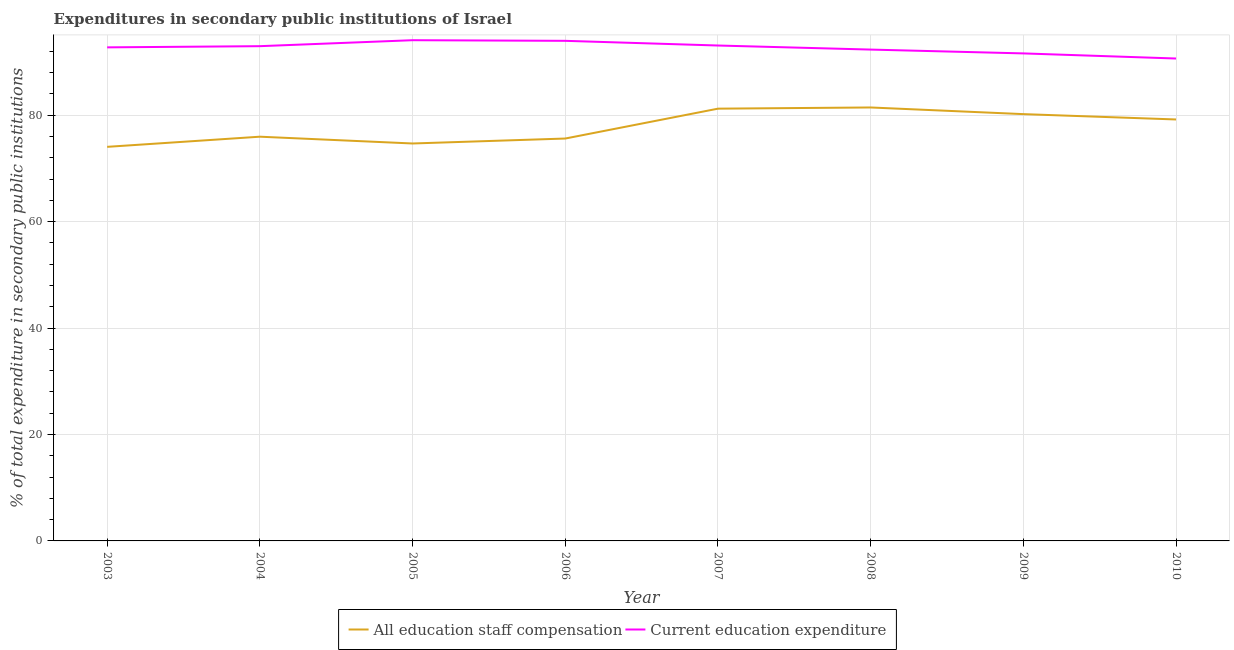How many different coloured lines are there?
Offer a terse response. 2. Does the line corresponding to expenditure in staff compensation intersect with the line corresponding to expenditure in education?
Provide a short and direct response. No. Is the number of lines equal to the number of legend labels?
Your response must be concise. Yes. What is the expenditure in staff compensation in 2010?
Give a very brief answer. 79.21. Across all years, what is the maximum expenditure in staff compensation?
Make the answer very short. 81.47. Across all years, what is the minimum expenditure in education?
Offer a very short reply. 90.67. What is the total expenditure in education in the graph?
Make the answer very short. 741.61. What is the difference between the expenditure in staff compensation in 2003 and that in 2008?
Your answer should be compact. -7.4. What is the difference between the expenditure in staff compensation in 2003 and the expenditure in education in 2009?
Provide a succinct answer. -17.56. What is the average expenditure in education per year?
Your response must be concise. 92.7. In the year 2003, what is the difference between the expenditure in staff compensation and expenditure in education?
Provide a short and direct response. -18.7. What is the ratio of the expenditure in staff compensation in 2006 to that in 2007?
Your answer should be compact. 0.93. What is the difference between the highest and the second highest expenditure in education?
Provide a short and direct response. 0.12. What is the difference between the highest and the lowest expenditure in staff compensation?
Your response must be concise. 7.4. In how many years, is the expenditure in education greater than the average expenditure in education taken over all years?
Offer a very short reply. 5. Does the expenditure in education monotonically increase over the years?
Offer a very short reply. No. Is the expenditure in education strictly greater than the expenditure in staff compensation over the years?
Your answer should be very brief. Yes. Does the graph contain any zero values?
Make the answer very short. No. Does the graph contain grids?
Give a very brief answer. Yes. Where does the legend appear in the graph?
Your answer should be compact. Bottom center. How are the legend labels stacked?
Keep it short and to the point. Horizontal. What is the title of the graph?
Offer a very short reply. Expenditures in secondary public institutions of Israel. What is the label or title of the Y-axis?
Your response must be concise. % of total expenditure in secondary public institutions. What is the % of total expenditure in secondary public institutions of All education staff compensation in 2003?
Offer a very short reply. 74.07. What is the % of total expenditure in secondary public institutions in Current education expenditure in 2003?
Provide a short and direct response. 92.77. What is the % of total expenditure in secondary public institutions of All education staff compensation in 2004?
Provide a short and direct response. 75.97. What is the % of total expenditure in secondary public institutions of Current education expenditure in 2004?
Offer a very short reply. 92.99. What is the % of total expenditure in secondary public institutions in All education staff compensation in 2005?
Make the answer very short. 74.7. What is the % of total expenditure in secondary public institutions of Current education expenditure in 2005?
Ensure brevity in your answer.  94.11. What is the % of total expenditure in secondary public institutions in All education staff compensation in 2006?
Ensure brevity in your answer.  75.63. What is the % of total expenditure in secondary public institutions in Current education expenditure in 2006?
Keep it short and to the point. 93.99. What is the % of total expenditure in secondary public institutions of All education staff compensation in 2007?
Keep it short and to the point. 81.24. What is the % of total expenditure in secondary public institutions of Current education expenditure in 2007?
Provide a succinct answer. 93.11. What is the % of total expenditure in secondary public institutions in All education staff compensation in 2008?
Provide a short and direct response. 81.47. What is the % of total expenditure in secondary public institutions of Current education expenditure in 2008?
Your answer should be compact. 92.35. What is the % of total expenditure in secondary public institutions in All education staff compensation in 2009?
Provide a short and direct response. 80.22. What is the % of total expenditure in secondary public institutions in Current education expenditure in 2009?
Offer a terse response. 91.63. What is the % of total expenditure in secondary public institutions of All education staff compensation in 2010?
Your answer should be compact. 79.21. What is the % of total expenditure in secondary public institutions in Current education expenditure in 2010?
Your response must be concise. 90.67. Across all years, what is the maximum % of total expenditure in secondary public institutions of All education staff compensation?
Keep it short and to the point. 81.47. Across all years, what is the maximum % of total expenditure in secondary public institutions in Current education expenditure?
Give a very brief answer. 94.11. Across all years, what is the minimum % of total expenditure in secondary public institutions of All education staff compensation?
Your answer should be compact. 74.07. Across all years, what is the minimum % of total expenditure in secondary public institutions in Current education expenditure?
Your answer should be very brief. 90.67. What is the total % of total expenditure in secondary public institutions in All education staff compensation in the graph?
Provide a short and direct response. 622.51. What is the total % of total expenditure in secondary public institutions of Current education expenditure in the graph?
Keep it short and to the point. 741.61. What is the difference between the % of total expenditure in secondary public institutions in All education staff compensation in 2003 and that in 2004?
Ensure brevity in your answer.  -1.91. What is the difference between the % of total expenditure in secondary public institutions in Current education expenditure in 2003 and that in 2004?
Keep it short and to the point. -0.22. What is the difference between the % of total expenditure in secondary public institutions in All education staff compensation in 2003 and that in 2005?
Your answer should be compact. -0.63. What is the difference between the % of total expenditure in secondary public institutions in Current education expenditure in 2003 and that in 2005?
Provide a short and direct response. -1.34. What is the difference between the % of total expenditure in secondary public institutions of All education staff compensation in 2003 and that in 2006?
Your answer should be compact. -1.56. What is the difference between the % of total expenditure in secondary public institutions of Current education expenditure in 2003 and that in 2006?
Give a very brief answer. -1.23. What is the difference between the % of total expenditure in secondary public institutions of All education staff compensation in 2003 and that in 2007?
Give a very brief answer. -7.18. What is the difference between the % of total expenditure in secondary public institutions in Current education expenditure in 2003 and that in 2007?
Provide a succinct answer. -0.35. What is the difference between the % of total expenditure in secondary public institutions in All education staff compensation in 2003 and that in 2008?
Ensure brevity in your answer.  -7.4. What is the difference between the % of total expenditure in secondary public institutions of Current education expenditure in 2003 and that in 2008?
Keep it short and to the point. 0.42. What is the difference between the % of total expenditure in secondary public institutions in All education staff compensation in 2003 and that in 2009?
Provide a succinct answer. -6.15. What is the difference between the % of total expenditure in secondary public institutions of Current education expenditure in 2003 and that in 2009?
Your answer should be compact. 1.14. What is the difference between the % of total expenditure in secondary public institutions of All education staff compensation in 2003 and that in 2010?
Your answer should be very brief. -5.15. What is the difference between the % of total expenditure in secondary public institutions of Current education expenditure in 2003 and that in 2010?
Offer a very short reply. 2.1. What is the difference between the % of total expenditure in secondary public institutions of All education staff compensation in 2004 and that in 2005?
Make the answer very short. 1.28. What is the difference between the % of total expenditure in secondary public institutions of Current education expenditure in 2004 and that in 2005?
Your response must be concise. -1.12. What is the difference between the % of total expenditure in secondary public institutions in All education staff compensation in 2004 and that in 2006?
Provide a succinct answer. 0.35. What is the difference between the % of total expenditure in secondary public institutions in Current education expenditure in 2004 and that in 2006?
Your answer should be very brief. -1. What is the difference between the % of total expenditure in secondary public institutions in All education staff compensation in 2004 and that in 2007?
Offer a terse response. -5.27. What is the difference between the % of total expenditure in secondary public institutions of Current education expenditure in 2004 and that in 2007?
Offer a terse response. -0.12. What is the difference between the % of total expenditure in secondary public institutions in All education staff compensation in 2004 and that in 2008?
Provide a succinct answer. -5.49. What is the difference between the % of total expenditure in secondary public institutions in Current education expenditure in 2004 and that in 2008?
Keep it short and to the point. 0.64. What is the difference between the % of total expenditure in secondary public institutions of All education staff compensation in 2004 and that in 2009?
Give a very brief answer. -4.24. What is the difference between the % of total expenditure in secondary public institutions of Current education expenditure in 2004 and that in 2009?
Ensure brevity in your answer.  1.36. What is the difference between the % of total expenditure in secondary public institutions in All education staff compensation in 2004 and that in 2010?
Provide a short and direct response. -3.24. What is the difference between the % of total expenditure in secondary public institutions in Current education expenditure in 2004 and that in 2010?
Keep it short and to the point. 2.32. What is the difference between the % of total expenditure in secondary public institutions of All education staff compensation in 2005 and that in 2006?
Provide a short and direct response. -0.93. What is the difference between the % of total expenditure in secondary public institutions of Current education expenditure in 2005 and that in 2006?
Ensure brevity in your answer.  0.12. What is the difference between the % of total expenditure in secondary public institutions in All education staff compensation in 2005 and that in 2007?
Offer a terse response. -6.54. What is the difference between the % of total expenditure in secondary public institutions in Current education expenditure in 2005 and that in 2007?
Your answer should be very brief. 1. What is the difference between the % of total expenditure in secondary public institutions of All education staff compensation in 2005 and that in 2008?
Give a very brief answer. -6.77. What is the difference between the % of total expenditure in secondary public institutions in Current education expenditure in 2005 and that in 2008?
Your answer should be compact. 1.76. What is the difference between the % of total expenditure in secondary public institutions of All education staff compensation in 2005 and that in 2009?
Your response must be concise. -5.52. What is the difference between the % of total expenditure in secondary public institutions of Current education expenditure in 2005 and that in 2009?
Make the answer very short. 2.48. What is the difference between the % of total expenditure in secondary public institutions of All education staff compensation in 2005 and that in 2010?
Keep it short and to the point. -4.51. What is the difference between the % of total expenditure in secondary public institutions in Current education expenditure in 2005 and that in 2010?
Your answer should be compact. 3.44. What is the difference between the % of total expenditure in secondary public institutions in All education staff compensation in 2006 and that in 2007?
Make the answer very short. -5.61. What is the difference between the % of total expenditure in secondary public institutions of All education staff compensation in 2006 and that in 2008?
Offer a terse response. -5.84. What is the difference between the % of total expenditure in secondary public institutions of Current education expenditure in 2006 and that in 2008?
Make the answer very short. 1.65. What is the difference between the % of total expenditure in secondary public institutions in All education staff compensation in 2006 and that in 2009?
Your response must be concise. -4.59. What is the difference between the % of total expenditure in secondary public institutions of Current education expenditure in 2006 and that in 2009?
Your answer should be compact. 2.36. What is the difference between the % of total expenditure in secondary public institutions of All education staff compensation in 2006 and that in 2010?
Keep it short and to the point. -3.58. What is the difference between the % of total expenditure in secondary public institutions of Current education expenditure in 2006 and that in 2010?
Give a very brief answer. 3.32. What is the difference between the % of total expenditure in secondary public institutions in All education staff compensation in 2007 and that in 2008?
Keep it short and to the point. -0.23. What is the difference between the % of total expenditure in secondary public institutions of Current education expenditure in 2007 and that in 2008?
Your answer should be very brief. 0.77. What is the difference between the % of total expenditure in secondary public institutions of All education staff compensation in 2007 and that in 2009?
Make the answer very short. 1.03. What is the difference between the % of total expenditure in secondary public institutions of Current education expenditure in 2007 and that in 2009?
Give a very brief answer. 1.48. What is the difference between the % of total expenditure in secondary public institutions of All education staff compensation in 2007 and that in 2010?
Ensure brevity in your answer.  2.03. What is the difference between the % of total expenditure in secondary public institutions of Current education expenditure in 2007 and that in 2010?
Provide a short and direct response. 2.44. What is the difference between the % of total expenditure in secondary public institutions in All education staff compensation in 2008 and that in 2009?
Give a very brief answer. 1.25. What is the difference between the % of total expenditure in secondary public institutions in Current education expenditure in 2008 and that in 2009?
Your response must be concise. 0.72. What is the difference between the % of total expenditure in secondary public institutions of All education staff compensation in 2008 and that in 2010?
Provide a short and direct response. 2.26. What is the difference between the % of total expenditure in secondary public institutions of Current education expenditure in 2008 and that in 2010?
Your answer should be compact. 1.68. What is the difference between the % of total expenditure in secondary public institutions in Current education expenditure in 2009 and that in 2010?
Give a very brief answer. 0.96. What is the difference between the % of total expenditure in secondary public institutions of All education staff compensation in 2003 and the % of total expenditure in secondary public institutions of Current education expenditure in 2004?
Make the answer very short. -18.92. What is the difference between the % of total expenditure in secondary public institutions of All education staff compensation in 2003 and the % of total expenditure in secondary public institutions of Current education expenditure in 2005?
Provide a succinct answer. -20.04. What is the difference between the % of total expenditure in secondary public institutions in All education staff compensation in 2003 and the % of total expenditure in secondary public institutions in Current education expenditure in 2006?
Your answer should be very brief. -19.93. What is the difference between the % of total expenditure in secondary public institutions in All education staff compensation in 2003 and the % of total expenditure in secondary public institutions in Current education expenditure in 2007?
Provide a succinct answer. -19.05. What is the difference between the % of total expenditure in secondary public institutions in All education staff compensation in 2003 and the % of total expenditure in secondary public institutions in Current education expenditure in 2008?
Keep it short and to the point. -18.28. What is the difference between the % of total expenditure in secondary public institutions of All education staff compensation in 2003 and the % of total expenditure in secondary public institutions of Current education expenditure in 2009?
Provide a succinct answer. -17.56. What is the difference between the % of total expenditure in secondary public institutions of All education staff compensation in 2003 and the % of total expenditure in secondary public institutions of Current education expenditure in 2010?
Keep it short and to the point. -16.6. What is the difference between the % of total expenditure in secondary public institutions of All education staff compensation in 2004 and the % of total expenditure in secondary public institutions of Current education expenditure in 2005?
Your response must be concise. -18.14. What is the difference between the % of total expenditure in secondary public institutions of All education staff compensation in 2004 and the % of total expenditure in secondary public institutions of Current education expenditure in 2006?
Keep it short and to the point. -18.02. What is the difference between the % of total expenditure in secondary public institutions in All education staff compensation in 2004 and the % of total expenditure in secondary public institutions in Current education expenditure in 2007?
Ensure brevity in your answer.  -17.14. What is the difference between the % of total expenditure in secondary public institutions of All education staff compensation in 2004 and the % of total expenditure in secondary public institutions of Current education expenditure in 2008?
Provide a succinct answer. -16.37. What is the difference between the % of total expenditure in secondary public institutions of All education staff compensation in 2004 and the % of total expenditure in secondary public institutions of Current education expenditure in 2009?
Make the answer very short. -15.66. What is the difference between the % of total expenditure in secondary public institutions of All education staff compensation in 2004 and the % of total expenditure in secondary public institutions of Current education expenditure in 2010?
Give a very brief answer. -14.7. What is the difference between the % of total expenditure in secondary public institutions in All education staff compensation in 2005 and the % of total expenditure in secondary public institutions in Current education expenditure in 2006?
Offer a terse response. -19.29. What is the difference between the % of total expenditure in secondary public institutions in All education staff compensation in 2005 and the % of total expenditure in secondary public institutions in Current education expenditure in 2007?
Provide a short and direct response. -18.41. What is the difference between the % of total expenditure in secondary public institutions in All education staff compensation in 2005 and the % of total expenditure in secondary public institutions in Current education expenditure in 2008?
Your answer should be compact. -17.65. What is the difference between the % of total expenditure in secondary public institutions in All education staff compensation in 2005 and the % of total expenditure in secondary public institutions in Current education expenditure in 2009?
Offer a terse response. -16.93. What is the difference between the % of total expenditure in secondary public institutions of All education staff compensation in 2005 and the % of total expenditure in secondary public institutions of Current education expenditure in 2010?
Keep it short and to the point. -15.97. What is the difference between the % of total expenditure in secondary public institutions in All education staff compensation in 2006 and the % of total expenditure in secondary public institutions in Current education expenditure in 2007?
Your response must be concise. -17.48. What is the difference between the % of total expenditure in secondary public institutions in All education staff compensation in 2006 and the % of total expenditure in secondary public institutions in Current education expenditure in 2008?
Your answer should be very brief. -16.72. What is the difference between the % of total expenditure in secondary public institutions in All education staff compensation in 2006 and the % of total expenditure in secondary public institutions in Current education expenditure in 2009?
Provide a succinct answer. -16. What is the difference between the % of total expenditure in secondary public institutions in All education staff compensation in 2006 and the % of total expenditure in secondary public institutions in Current education expenditure in 2010?
Give a very brief answer. -15.04. What is the difference between the % of total expenditure in secondary public institutions of All education staff compensation in 2007 and the % of total expenditure in secondary public institutions of Current education expenditure in 2008?
Provide a short and direct response. -11.1. What is the difference between the % of total expenditure in secondary public institutions in All education staff compensation in 2007 and the % of total expenditure in secondary public institutions in Current education expenditure in 2009?
Keep it short and to the point. -10.39. What is the difference between the % of total expenditure in secondary public institutions of All education staff compensation in 2007 and the % of total expenditure in secondary public institutions of Current education expenditure in 2010?
Ensure brevity in your answer.  -9.43. What is the difference between the % of total expenditure in secondary public institutions in All education staff compensation in 2008 and the % of total expenditure in secondary public institutions in Current education expenditure in 2009?
Ensure brevity in your answer.  -10.16. What is the difference between the % of total expenditure in secondary public institutions in All education staff compensation in 2008 and the % of total expenditure in secondary public institutions in Current education expenditure in 2010?
Your answer should be compact. -9.2. What is the difference between the % of total expenditure in secondary public institutions of All education staff compensation in 2009 and the % of total expenditure in secondary public institutions of Current education expenditure in 2010?
Ensure brevity in your answer.  -10.45. What is the average % of total expenditure in secondary public institutions in All education staff compensation per year?
Your answer should be compact. 77.81. What is the average % of total expenditure in secondary public institutions in Current education expenditure per year?
Make the answer very short. 92.7. In the year 2003, what is the difference between the % of total expenditure in secondary public institutions of All education staff compensation and % of total expenditure in secondary public institutions of Current education expenditure?
Your answer should be very brief. -18.7. In the year 2004, what is the difference between the % of total expenditure in secondary public institutions in All education staff compensation and % of total expenditure in secondary public institutions in Current education expenditure?
Provide a short and direct response. -17.01. In the year 2005, what is the difference between the % of total expenditure in secondary public institutions in All education staff compensation and % of total expenditure in secondary public institutions in Current education expenditure?
Your answer should be very brief. -19.41. In the year 2006, what is the difference between the % of total expenditure in secondary public institutions in All education staff compensation and % of total expenditure in secondary public institutions in Current education expenditure?
Your answer should be compact. -18.36. In the year 2007, what is the difference between the % of total expenditure in secondary public institutions of All education staff compensation and % of total expenditure in secondary public institutions of Current education expenditure?
Offer a terse response. -11.87. In the year 2008, what is the difference between the % of total expenditure in secondary public institutions of All education staff compensation and % of total expenditure in secondary public institutions of Current education expenditure?
Offer a terse response. -10.88. In the year 2009, what is the difference between the % of total expenditure in secondary public institutions in All education staff compensation and % of total expenditure in secondary public institutions in Current education expenditure?
Your response must be concise. -11.41. In the year 2010, what is the difference between the % of total expenditure in secondary public institutions of All education staff compensation and % of total expenditure in secondary public institutions of Current education expenditure?
Ensure brevity in your answer.  -11.46. What is the ratio of the % of total expenditure in secondary public institutions in All education staff compensation in 2003 to that in 2004?
Offer a terse response. 0.97. What is the ratio of the % of total expenditure in secondary public institutions in Current education expenditure in 2003 to that in 2004?
Your answer should be compact. 1. What is the ratio of the % of total expenditure in secondary public institutions in Current education expenditure in 2003 to that in 2005?
Offer a terse response. 0.99. What is the ratio of the % of total expenditure in secondary public institutions in All education staff compensation in 2003 to that in 2006?
Provide a short and direct response. 0.98. What is the ratio of the % of total expenditure in secondary public institutions of All education staff compensation in 2003 to that in 2007?
Make the answer very short. 0.91. What is the ratio of the % of total expenditure in secondary public institutions of All education staff compensation in 2003 to that in 2009?
Provide a short and direct response. 0.92. What is the ratio of the % of total expenditure in secondary public institutions in Current education expenditure in 2003 to that in 2009?
Your answer should be very brief. 1.01. What is the ratio of the % of total expenditure in secondary public institutions of All education staff compensation in 2003 to that in 2010?
Keep it short and to the point. 0.94. What is the ratio of the % of total expenditure in secondary public institutions of Current education expenditure in 2003 to that in 2010?
Offer a terse response. 1.02. What is the ratio of the % of total expenditure in secondary public institutions of All education staff compensation in 2004 to that in 2005?
Ensure brevity in your answer.  1.02. What is the ratio of the % of total expenditure in secondary public institutions of Current education expenditure in 2004 to that in 2005?
Provide a succinct answer. 0.99. What is the ratio of the % of total expenditure in secondary public institutions in All education staff compensation in 2004 to that in 2006?
Ensure brevity in your answer.  1. What is the ratio of the % of total expenditure in secondary public institutions in Current education expenditure in 2004 to that in 2006?
Ensure brevity in your answer.  0.99. What is the ratio of the % of total expenditure in secondary public institutions in All education staff compensation in 2004 to that in 2007?
Your answer should be compact. 0.94. What is the ratio of the % of total expenditure in secondary public institutions in Current education expenditure in 2004 to that in 2007?
Your response must be concise. 1. What is the ratio of the % of total expenditure in secondary public institutions of All education staff compensation in 2004 to that in 2008?
Offer a terse response. 0.93. What is the ratio of the % of total expenditure in secondary public institutions of Current education expenditure in 2004 to that in 2008?
Ensure brevity in your answer.  1.01. What is the ratio of the % of total expenditure in secondary public institutions of All education staff compensation in 2004 to that in 2009?
Ensure brevity in your answer.  0.95. What is the ratio of the % of total expenditure in secondary public institutions in Current education expenditure in 2004 to that in 2009?
Make the answer very short. 1.01. What is the ratio of the % of total expenditure in secondary public institutions in All education staff compensation in 2004 to that in 2010?
Make the answer very short. 0.96. What is the ratio of the % of total expenditure in secondary public institutions of Current education expenditure in 2004 to that in 2010?
Make the answer very short. 1.03. What is the ratio of the % of total expenditure in secondary public institutions of All education staff compensation in 2005 to that in 2007?
Ensure brevity in your answer.  0.92. What is the ratio of the % of total expenditure in secondary public institutions in Current education expenditure in 2005 to that in 2007?
Offer a terse response. 1.01. What is the ratio of the % of total expenditure in secondary public institutions of All education staff compensation in 2005 to that in 2008?
Keep it short and to the point. 0.92. What is the ratio of the % of total expenditure in secondary public institutions of Current education expenditure in 2005 to that in 2008?
Provide a short and direct response. 1.02. What is the ratio of the % of total expenditure in secondary public institutions of All education staff compensation in 2005 to that in 2009?
Give a very brief answer. 0.93. What is the ratio of the % of total expenditure in secondary public institutions in Current education expenditure in 2005 to that in 2009?
Give a very brief answer. 1.03. What is the ratio of the % of total expenditure in secondary public institutions in All education staff compensation in 2005 to that in 2010?
Offer a very short reply. 0.94. What is the ratio of the % of total expenditure in secondary public institutions of Current education expenditure in 2005 to that in 2010?
Make the answer very short. 1.04. What is the ratio of the % of total expenditure in secondary public institutions in All education staff compensation in 2006 to that in 2007?
Your answer should be very brief. 0.93. What is the ratio of the % of total expenditure in secondary public institutions in Current education expenditure in 2006 to that in 2007?
Make the answer very short. 1.01. What is the ratio of the % of total expenditure in secondary public institutions of All education staff compensation in 2006 to that in 2008?
Your answer should be very brief. 0.93. What is the ratio of the % of total expenditure in secondary public institutions in Current education expenditure in 2006 to that in 2008?
Provide a succinct answer. 1.02. What is the ratio of the % of total expenditure in secondary public institutions of All education staff compensation in 2006 to that in 2009?
Your answer should be very brief. 0.94. What is the ratio of the % of total expenditure in secondary public institutions in Current education expenditure in 2006 to that in 2009?
Provide a short and direct response. 1.03. What is the ratio of the % of total expenditure in secondary public institutions of All education staff compensation in 2006 to that in 2010?
Offer a very short reply. 0.95. What is the ratio of the % of total expenditure in secondary public institutions in Current education expenditure in 2006 to that in 2010?
Give a very brief answer. 1.04. What is the ratio of the % of total expenditure in secondary public institutions of Current education expenditure in 2007 to that in 2008?
Offer a very short reply. 1.01. What is the ratio of the % of total expenditure in secondary public institutions of All education staff compensation in 2007 to that in 2009?
Offer a very short reply. 1.01. What is the ratio of the % of total expenditure in secondary public institutions of Current education expenditure in 2007 to that in 2009?
Give a very brief answer. 1.02. What is the ratio of the % of total expenditure in secondary public institutions in All education staff compensation in 2007 to that in 2010?
Make the answer very short. 1.03. What is the ratio of the % of total expenditure in secondary public institutions of Current education expenditure in 2007 to that in 2010?
Make the answer very short. 1.03. What is the ratio of the % of total expenditure in secondary public institutions in All education staff compensation in 2008 to that in 2009?
Offer a very short reply. 1.02. What is the ratio of the % of total expenditure in secondary public institutions of Current education expenditure in 2008 to that in 2009?
Your response must be concise. 1.01. What is the ratio of the % of total expenditure in secondary public institutions of All education staff compensation in 2008 to that in 2010?
Give a very brief answer. 1.03. What is the ratio of the % of total expenditure in secondary public institutions of Current education expenditure in 2008 to that in 2010?
Provide a short and direct response. 1.02. What is the ratio of the % of total expenditure in secondary public institutions of All education staff compensation in 2009 to that in 2010?
Offer a terse response. 1.01. What is the ratio of the % of total expenditure in secondary public institutions in Current education expenditure in 2009 to that in 2010?
Your response must be concise. 1.01. What is the difference between the highest and the second highest % of total expenditure in secondary public institutions in All education staff compensation?
Provide a short and direct response. 0.23. What is the difference between the highest and the second highest % of total expenditure in secondary public institutions of Current education expenditure?
Offer a terse response. 0.12. What is the difference between the highest and the lowest % of total expenditure in secondary public institutions of All education staff compensation?
Your answer should be very brief. 7.4. What is the difference between the highest and the lowest % of total expenditure in secondary public institutions in Current education expenditure?
Make the answer very short. 3.44. 